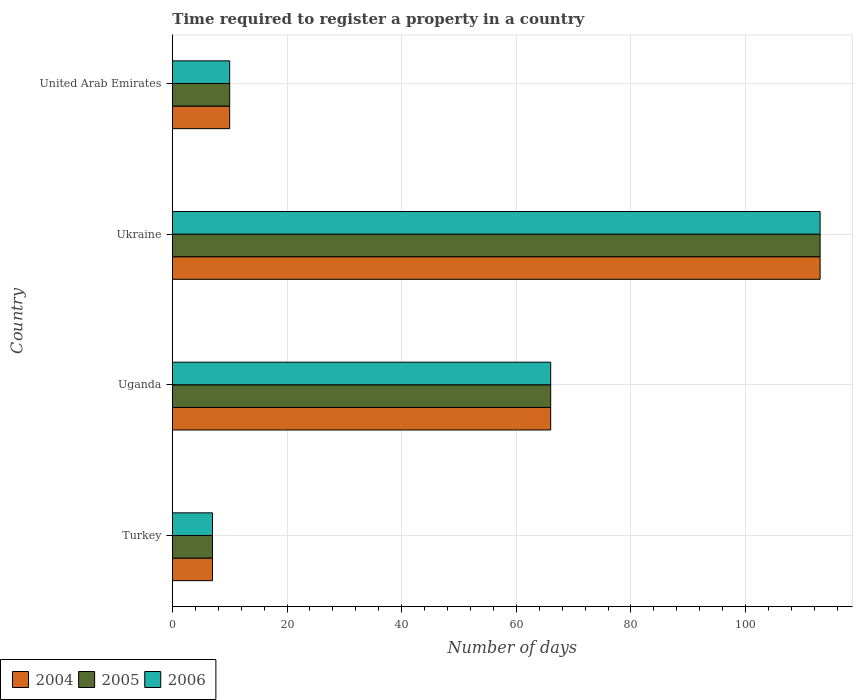How many different coloured bars are there?
Your response must be concise. 3. How many groups of bars are there?
Provide a short and direct response. 4. How many bars are there on the 1st tick from the top?
Your answer should be compact. 3. What is the label of the 3rd group of bars from the top?
Ensure brevity in your answer.  Uganda. Across all countries, what is the maximum number of days required to register a property in 2006?
Keep it short and to the point. 113. Across all countries, what is the minimum number of days required to register a property in 2006?
Provide a succinct answer. 7. In which country was the number of days required to register a property in 2005 maximum?
Give a very brief answer. Ukraine. In which country was the number of days required to register a property in 2006 minimum?
Provide a succinct answer. Turkey. What is the total number of days required to register a property in 2004 in the graph?
Give a very brief answer. 196. What is the difference between the number of days required to register a property in 2005 in Turkey and that in Uganda?
Ensure brevity in your answer.  -59. What is the difference between the number of days required to register a property in 2005 in Uganda and the number of days required to register a property in 2006 in United Arab Emirates?
Make the answer very short. 56. In how many countries, is the number of days required to register a property in 2005 greater than 24 days?
Your answer should be compact. 2. What is the ratio of the number of days required to register a property in 2004 in Turkey to that in United Arab Emirates?
Provide a short and direct response. 0.7. Is the difference between the number of days required to register a property in 2005 in Turkey and Ukraine greater than the difference between the number of days required to register a property in 2006 in Turkey and Ukraine?
Your answer should be compact. No. What is the difference between the highest and the lowest number of days required to register a property in 2004?
Your response must be concise. 106. In how many countries, is the number of days required to register a property in 2004 greater than the average number of days required to register a property in 2004 taken over all countries?
Your answer should be very brief. 2. Is the sum of the number of days required to register a property in 2006 in Turkey and Ukraine greater than the maximum number of days required to register a property in 2004 across all countries?
Ensure brevity in your answer.  Yes. What does the 1st bar from the top in Uganda represents?
Make the answer very short. 2006. What does the 3rd bar from the bottom in United Arab Emirates represents?
Offer a very short reply. 2006. Is it the case that in every country, the sum of the number of days required to register a property in 2006 and number of days required to register a property in 2004 is greater than the number of days required to register a property in 2005?
Offer a terse response. Yes. How many countries are there in the graph?
Ensure brevity in your answer.  4. What is the difference between two consecutive major ticks on the X-axis?
Make the answer very short. 20. Does the graph contain grids?
Give a very brief answer. Yes. What is the title of the graph?
Ensure brevity in your answer.  Time required to register a property in a country. What is the label or title of the X-axis?
Keep it short and to the point. Number of days. What is the label or title of the Y-axis?
Your response must be concise. Country. What is the Number of days of 2004 in Turkey?
Ensure brevity in your answer.  7. What is the Number of days of 2006 in Turkey?
Offer a very short reply. 7. What is the Number of days of 2005 in Uganda?
Your answer should be very brief. 66. What is the Number of days in 2004 in Ukraine?
Your response must be concise. 113. What is the Number of days of 2005 in Ukraine?
Your response must be concise. 113. What is the Number of days in 2006 in Ukraine?
Your answer should be very brief. 113. What is the Number of days of 2006 in United Arab Emirates?
Offer a very short reply. 10. Across all countries, what is the maximum Number of days in 2004?
Your response must be concise. 113. Across all countries, what is the maximum Number of days of 2005?
Your answer should be very brief. 113. Across all countries, what is the maximum Number of days in 2006?
Keep it short and to the point. 113. Across all countries, what is the minimum Number of days of 2004?
Offer a very short reply. 7. Across all countries, what is the minimum Number of days of 2005?
Provide a succinct answer. 7. What is the total Number of days in 2004 in the graph?
Your answer should be compact. 196. What is the total Number of days in 2005 in the graph?
Offer a terse response. 196. What is the total Number of days of 2006 in the graph?
Provide a succinct answer. 196. What is the difference between the Number of days in 2004 in Turkey and that in Uganda?
Keep it short and to the point. -59. What is the difference between the Number of days of 2005 in Turkey and that in Uganda?
Your response must be concise. -59. What is the difference between the Number of days of 2006 in Turkey and that in Uganda?
Offer a very short reply. -59. What is the difference between the Number of days in 2004 in Turkey and that in Ukraine?
Provide a short and direct response. -106. What is the difference between the Number of days of 2005 in Turkey and that in Ukraine?
Ensure brevity in your answer.  -106. What is the difference between the Number of days of 2006 in Turkey and that in Ukraine?
Your answer should be very brief. -106. What is the difference between the Number of days in 2004 in Turkey and that in United Arab Emirates?
Offer a terse response. -3. What is the difference between the Number of days of 2006 in Turkey and that in United Arab Emirates?
Give a very brief answer. -3. What is the difference between the Number of days of 2004 in Uganda and that in Ukraine?
Ensure brevity in your answer.  -47. What is the difference between the Number of days in 2005 in Uganda and that in Ukraine?
Your answer should be very brief. -47. What is the difference between the Number of days in 2006 in Uganda and that in Ukraine?
Keep it short and to the point. -47. What is the difference between the Number of days of 2004 in Ukraine and that in United Arab Emirates?
Give a very brief answer. 103. What is the difference between the Number of days of 2005 in Ukraine and that in United Arab Emirates?
Give a very brief answer. 103. What is the difference between the Number of days of 2006 in Ukraine and that in United Arab Emirates?
Your answer should be compact. 103. What is the difference between the Number of days in 2004 in Turkey and the Number of days in 2005 in Uganda?
Ensure brevity in your answer.  -59. What is the difference between the Number of days in 2004 in Turkey and the Number of days in 2006 in Uganda?
Make the answer very short. -59. What is the difference between the Number of days of 2005 in Turkey and the Number of days of 2006 in Uganda?
Provide a short and direct response. -59. What is the difference between the Number of days in 2004 in Turkey and the Number of days in 2005 in Ukraine?
Provide a short and direct response. -106. What is the difference between the Number of days of 2004 in Turkey and the Number of days of 2006 in Ukraine?
Your answer should be very brief. -106. What is the difference between the Number of days of 2005 in Turkey and the Number of days of 2006 in Ukraine?
Keep it short and to the point. -106. What is the difference between the Number of days of 2004 in Turkey and the Number of days of 2005 in United Arab Emirates?
Keep it short and to the point. -3. What is the difference between the Number of days in 2004 in Turkey and the Number of days in 2006 in United Arab Emirates?
Provide a short and direct response. -3. What is the difference between the Number of days of 2004 in Uganda and the Number of days of 2005 in Ukraine?
Keep it short and to the point. -47. What is the difference between the Number of days of 2004 in Uganda and the Number of days of 2006 in Ukraine?
Your answer should be very brief. -47. What is the difference between the Number of days in 2005 in Uganda and the Number of days in 2006 in Ukraine?
Give a very brief answer. -47. What is the difference between the Number of days of 2005 in Uganda and the Number of days of 2006 in United Arab Emirates?
Ensure brevity in your answer.  56. What is the difference between the Number of days in 2004 in Ukraine and the Number of days in 2005 in United Arab Emirates?
Ensure brevity in your answer.  103. What is the difference between the Number of days of 2004 in Ukraine and the Number of days of 2006 in United Arab Emirates?
Provide a short and direct response. 103. What is the difference between the Number of days of 2005 in Ukraine and the Number of days of 2006 in United Arab Emirates?
Provide a succinct answer. 103. What is the average Number of days in 2004 per country?
Your answer should be compact. 49. What is the average Number of days of 2005 per country?
Keep it short and to the point. 49. What is the difference between the Number of days in 2004 and Number of days in 2006 in Turkey?
Give a very brief answer. 0. What is the difference between the Number of days in 2005 and Number of days in 2006 in Turkey?
Your answer should be compact. 0. What is the difference between the Number of days in 2004 and Number of days in 2006 in Uganda?
Ensure brevity in your answer.  0. What is the difference between the Number of days in 2004 and Number of days in 2005 in Ukraine?
Offer a very short reply. 0. What is the difference between the Number of days of 2004 and Number of days of 2006 in Ukraine?
Your response must be concise. 0. What is the difference between the Number of days of 2004 and Number of days of 2005 in United Arab Emirates?
Your response must be concise. 0. What is the difference between the Number of days of 2005 and Number of days of 2006 in United Arab Emirates?
Offer a terse response. 0. What is the ratio of the Number of days in 2004 in Turkey to that in Uganda?
Make the answer very short. 0.11. What is the ratio of the Number of days of 2005 in Turkey to that in Uganda?
Your response must be concise. 0.11. What is the ratio of the Number of days in 2006 in Turkey to that in Uganda?
Provide a succinct answer. 0.11. What is the ratio of the Number of days in 2004 in Turkey to that in Ukraine?
Provide a short and direct response. 0.06. What is the ratio of the Number of days in 2005 in Turkey to that in Ukraine?
Provide a succinct answer. 0.06. What is the ratio of the Number of days in 2006 in Turkey to that in Ukraine?
Make the answer very short. 0.06. What is the ratio of the Number of days in 2004 in Uganda to that in Ukraine?
Offer a terse response. 0.58. What is the ratio of the Number of days in 2005 in Uganda to that in Ukraine?
Ensure brevity in your answer.  0.58. What is the ratio of the Number of days of 2006 in Uganda to that in Ukraine?
Your answer should be compact. 0.58. What is the ratio of the Number of days in 2005 in Uganda to that in United Arab Emirates?
Your answer should be compact. 6.6. What is the ratio of the Number of days of 2004 in Ukraine to that in United Arab Emirates?
Make the answer very short. 11.3. What is the ratio of the Number of days in 2005 in Ukraine to that in United Arab Emirates?
Ensure brevity in your answer.  11.3. What is the ratio of the Number of days in 2006 in Ukraine to that in United Arab Emirates?
Make the answer very short. 11.3. What is the difference between the highest and the second highest Number of days in 2005?
Keep it short and to the point. 47. What is the difference between the highest and the second highest Number of days in 2006?
Provide a succinct answer. 47. What is the difference between the highest and the lowest Number of days in 2004?
Your answer should be compact. 106. What is the difference between the highest and the lowest Number of days of 2005?
Your response must be concise. 106. What is the difference between the highest and the lowest Number of days of 2006?
Ensure brevity in your answer.  106. 